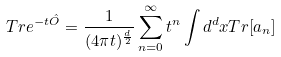<formula> <loc_0><loc_0><loc_500><loc_500>T r e ^ { - t \hat { O } } = \frac { 1 } { ( 4 \pi t ) ^ { \frac { d } { 2 } } } \sum _ { n = 0 } ^ { \infty } t ^ { n } \int d ^ { d } x T r [ a _ { n } ]</formula> 